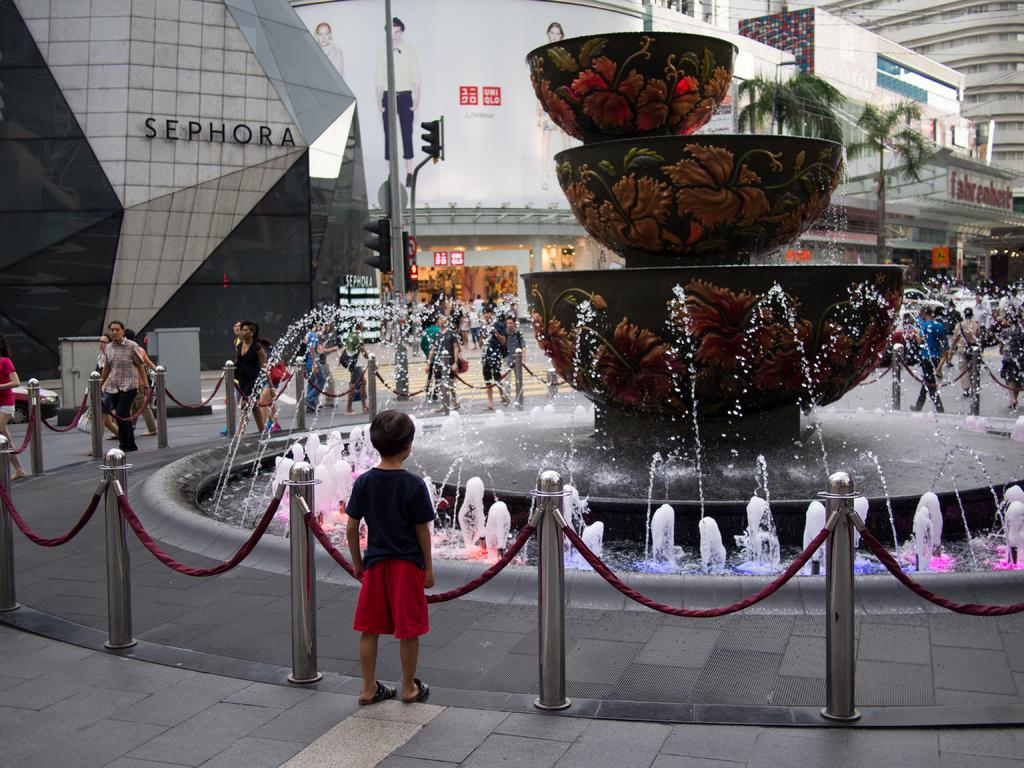<image>
Write a terse but informative summary of the picture. A young boy stares at a fountain outside a Sephora store. 